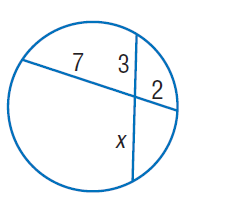Question: Find x. Round to the nearest tenth if necessary. Assume that segments that appear to be tangent are tangent.
Choices:
A. 2
B. 3
C. 4.7
D. 7
Answer with the letter. Answer: C 